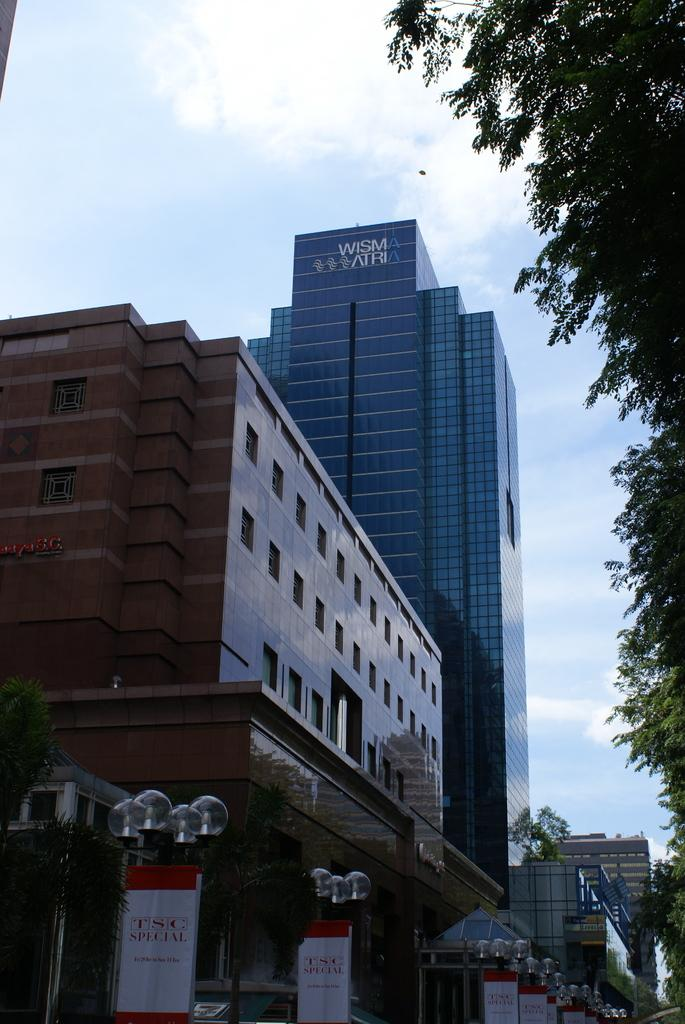<image>
Give a short and clear explanation of the subsequent image. A view of the WISMA ATRIA building in front of a red brick building 